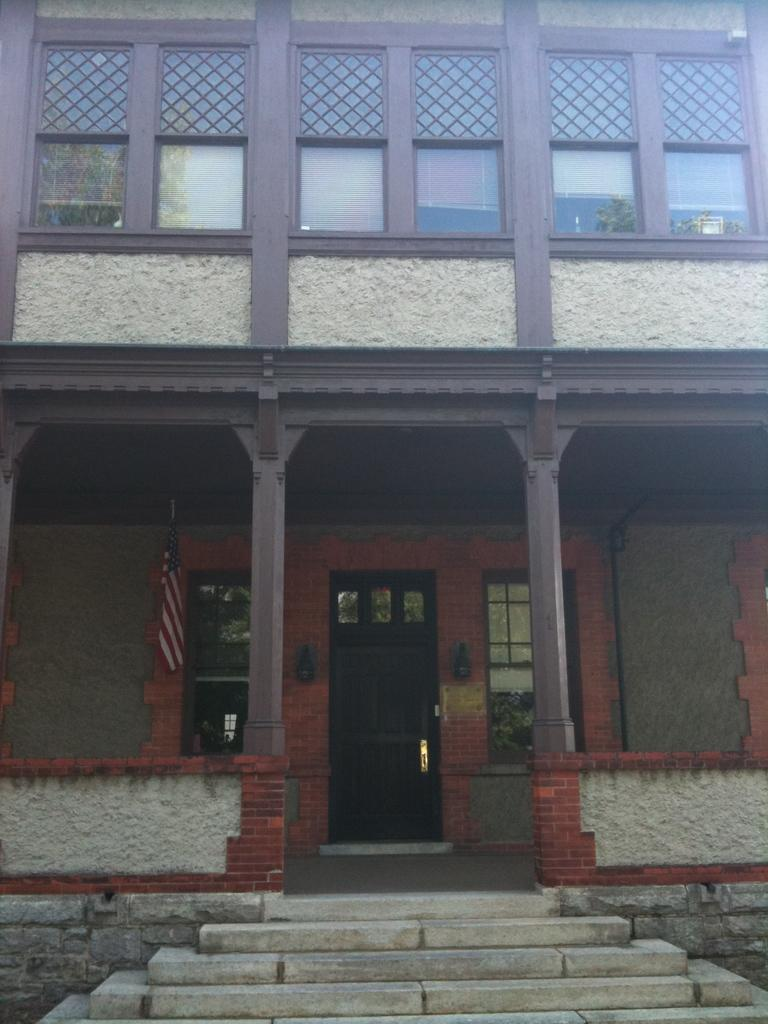What type of structure is visible in the image? There is a building in the image. What architectural feature is present in front of the building? There are stairs in front of the building. How can one enter the building? There is a door in the center of the building. What are some openings in the building that allow light and air to enter? There are windows in the building. What is the symbol or emblem attached to the building? There is a flag in the image. Are there any windows located higher up on the building? Yes, there are windows at the top of the building. What type of treatment is the dad receiving in the image? There is no dad or treatment present in the image; it only features a building with various architectural features. 